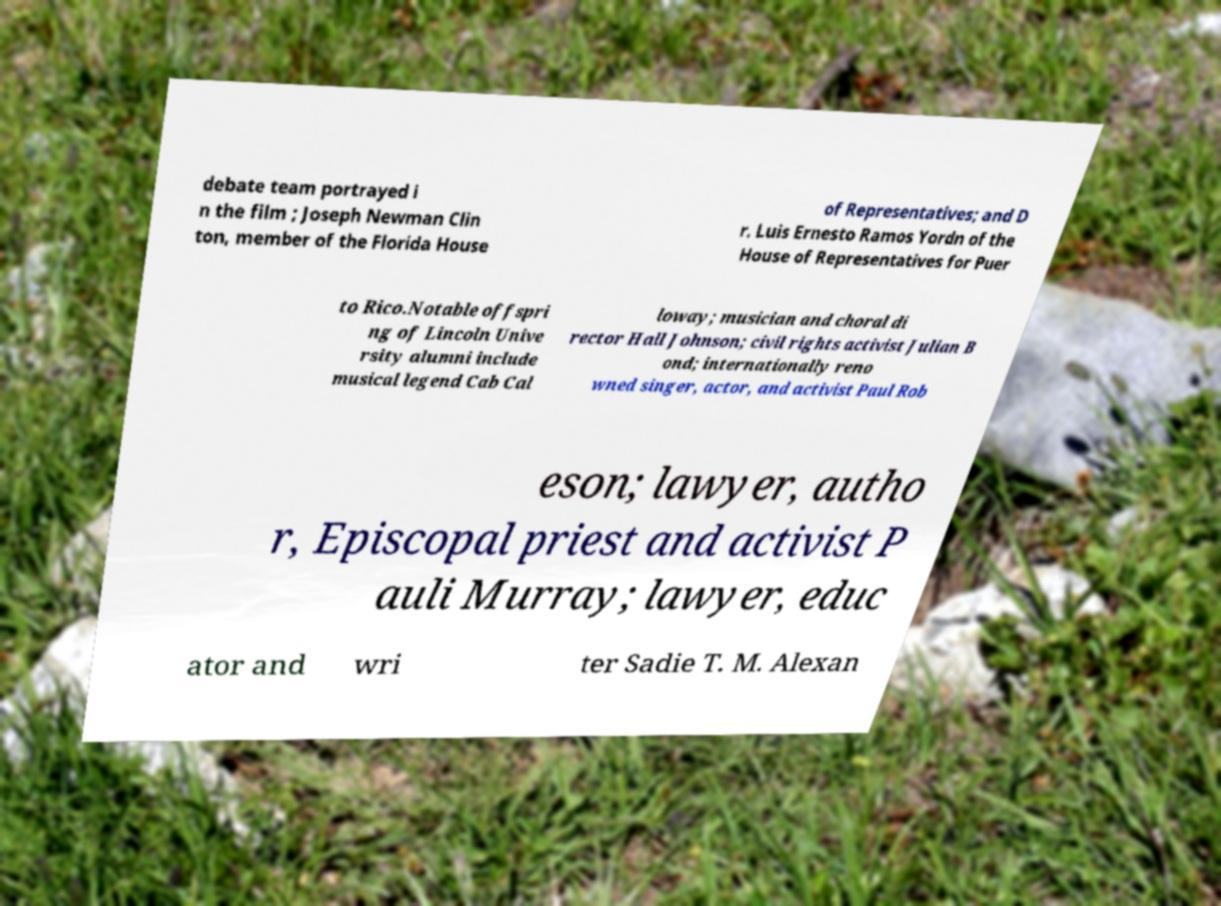Please read and relay the text visible in this image. What does it say? debate team portrayed i n the film ; Joseph Newman Clin ton, member of the Florida House of Representatives; and D r. Luis Ernesto Ramos Yordn of the House of Representatives for Puer to Rico.Notable offspri ng of Lincoln Unive rsity alumni include musical legend Cab Cal loway; musician and choral di rector Hall Johnson; civil rights activist Julian B ond; internationally reno wned singer, actor, and activist Paul Rob eson; lawyer, autho r, Episcopal priest and activist P auli Murray; lawyer, educ ator and wri ter Sadie T. M. Alexan 